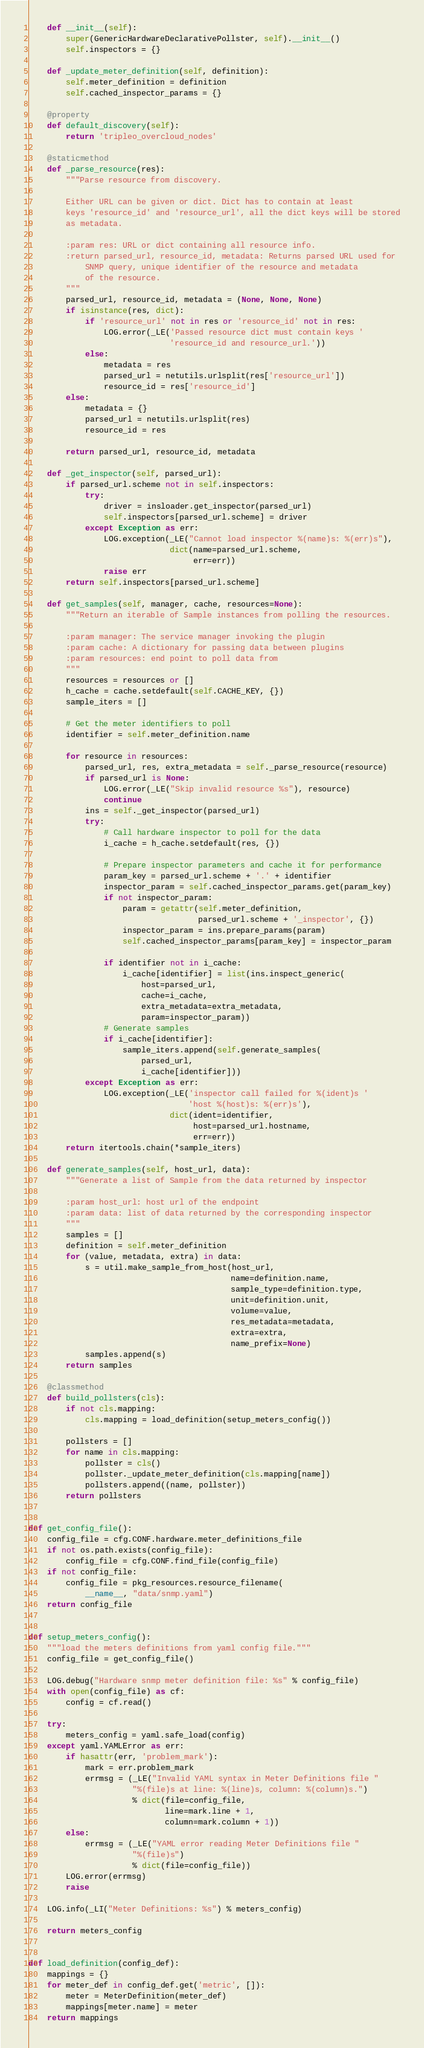<code> <loc_0><loc_0><loc_500><loc_500><_Python_>    def __init__(self):
        super(GenericHardwareDeclarativePollster, self).__init__()
        self.inspectors = {}

    def _update_meter_definition(self, definition):
        self.meter_definition = definition
        self.cached_inspector_params = {}

    @property
    def default_discovery(self):
        return 'tripleo_overcloud_nodes'

    @staticmethod
    def _parse_resource(res):
        """Parse resource from discovery.

        Either URL can be given or dict. Dict has to contain at least
        keys 'resource_id' and 'resource_url', all the dict keys will be stored
        as metadata.

        :param res: URL or dict containing all resource info.
        :return parsed_url, resource_id, metadata: Returns parsed URL used for
            SNMP query, unique identifier of the resource and metadata
            of the resource.
        """
        parsed_url, resource_id, metadata = (None, None, None)
        if isinstance(res, dict):
            if 'resource_url' not in res or 'resource_id' not in res:
                LOG.error(_LE('Passed resource dict must contain keys '
                              'resource_id and resource_url.'))
            else:
                metadata = res
                parsed_url = netutils.urlsplit(res['resource_url'])
                resource_id = res['resource_id']
        else:
            metadata = {}
            parsed_url = netutils.urlsplit(res)
            resource_id = res

        return parsed_url, resource_id, metadata

    def _get_inspector(self, parsed_url):
        if parsed_url.scheme not in self.inspectors:
            try:
                driver = insloader.get_inspector(parsed_url)
                self.inspectors[parsed_url.scheme] = driver
            except Exception as err:
                LOG.exception(_LE("Cannot load inspector %(name)s: %(err)s"),
                              dict(name=parsed_url.scheme,
                                   err=err))
                raise err
        return self.inspectors[parsed_url.scheme]

    def get_samples(self, manager, cache, resources=None):
        """Return an iterable of Sample instances from polling the resources.

        :param manager: The service manager invoking the plugin
        :param cache: A dictionary for passing data between plugins
        :param resources: end point to poll data from
        """
        resources = resources or []
        h_cache = cache.setdefault(self.CACHE_KEY, {})
        sample_iters = []

        # Get the meter identifiers to poll
        identifier = self.meter_definition.name

        for resource in resources:
            parsed_url, res, extra_metadata = self._parse_resource(resource)
            if parsed_url is None:
                LOG.error(_LE("Skip invalid resource %s"), resource)
                continue
            ins = self._get_inspector(parsed_url)
            try:
                # Call hardware inspector to poll for the data
                i_cache = h_cache.setdefault(res, {})

                # Prepare inspector parameters and cache it for performance
                param_key = parsed_url.scheme + '.' + identifier
                inspector_param = self.cached_inspector_params.get(param_key)
                if not inspector_param:
                    param = getattr(self.meter_definition,
                                    parsed_url.scheme + '_inspector', {})
                    inspector_param = ins.prepare_params(param)
                    self.cached_inspector_params[param_key] = inspector_param

                if identifier not in i_cache:
                    i_cache[identifier] = list(ins.inspect_generic(
                        host=parsed_url,
                        cache=i_cache,
                        extra_metadata=extra_metadata,
                        param=inspector_param))
                # Generate samples
                if i_cache[identifier]:
                    sample_iters.append(self.generate_samples(
                        parsed_url,
                        i_cache[identifier]))
            except Exception as err:
                LOG.exception(_LE('inspector call failed for %(ident)s '
                                  'host %(host)s: %(err)s'),
                              dict(ident=identifier,
                                   host=parsed_url.hostname,
                                   err=err))
        return itertools.chain(*sample_iters)

    def generate_samples(self, host_url, data):
        """Generate a list of Sample from the data returned by inspector

        :param host_url: host url of the endpoint
        :param data: list of data returned by the corresponding inspector
        """
        samples = []
        definition = self.meter_definition
        for (value, metadata, extra) in data:
            s = util.make_sample_from_host(host_url,
                                           name=definition.name,
                                           sample_type=definition.type,
                                           unit=definition.unit,
                                           volume=value,
                                           res_metadata=metadata,
                                           extra=extra,
                                           name_prefix=None)
            samples.append(s)
        return samples

    @classmethod
    def build_pollsters(cls):
        if not cls.mapping:
            cls.mapping = load_definition(setup_meters_config())

        pollsters = []
        for name in cls.mapping:
            pollster = cls()
            pollster._update_meter_definition(cls.mapping[name])
            pollsters.append((name, pollster))
        return pollsters


def get_config_file():
    config_file = cfg.CONF.hardware.meter_definitions_file
    if not os.path.exists(config_file):
        config_file = cfg.CONF.find_file(config_file)
    if not config_file:
        config_file = pkg_resources.resource_filename(
            __name__, "data/snmp.yaml")
    return config_file


def setup_meters_config():
    """load the meters definitions from yaml config file."""
    config_file = get_config_file()

    LOG.debug("Hardware snmp meter definition file: %s" % config_file)
    with open(config_file) as cf:
        config = cf.read()

    try:
        meters_config = yaml.safe_load(config)
    except yaml.YAMLError as err:
        if hasattr(err, 'problem_mark'):
            mark = err.problem_mark
            errmsg = (_LE("Invalid YAML syntax in Meter Definitions file "
                      "%(file)s at line: %(line)s, column: %(column)s.")
                      % dict(file=config_file,
                             line=mark.line + 1,
                             column=mark.column + 1))
        else:
            errmsg = (_LE("YAML error reading Meter Definitions file "
                      "%(file)s")
                      % dict(file=config_file))
        LOG.error(errmsg)
        raise

    LOG.info(_LI("Meter Definitions: %s") % meters_config)

    return meters_config


def load_definition(config_def):
    mappings = {}
    for meter_def in config_def.get('metric', []):
        meter = MeterDefinition(meter_def)
        mappings[meter.name] = meter
    return mappings
</code> 